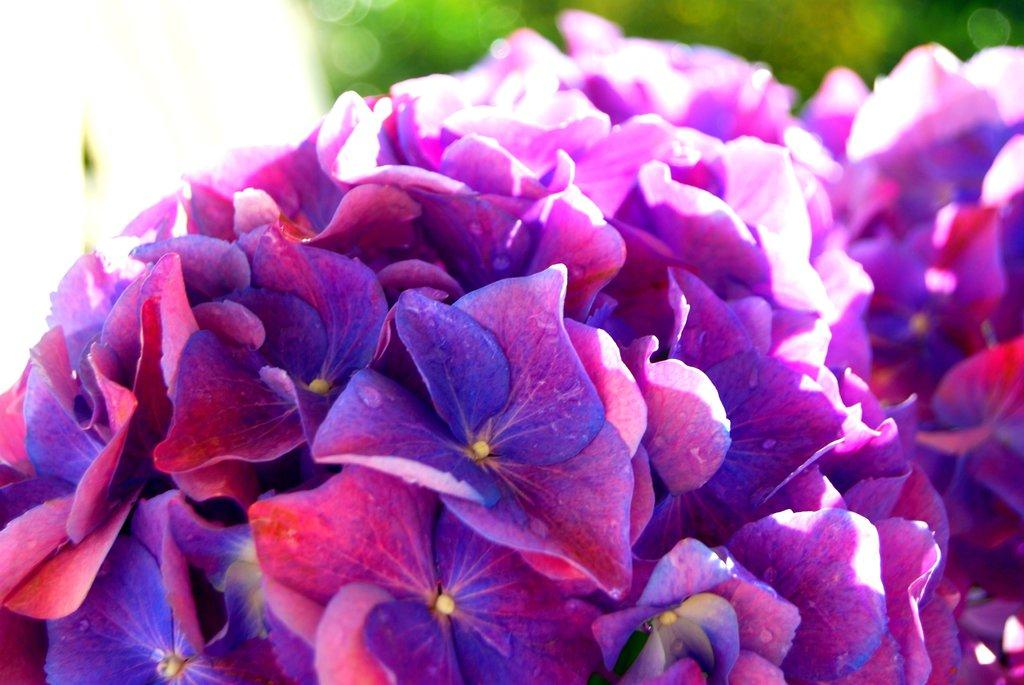What is the main subject of the image? The main subject of the image is a close-up view of flowers. Can you describe the flowers in the image? Unfortunately, the facts provided do not give any details about the flowers, so we cannot describe them. What might be the purpose of taking a close-up view of flowers? A close-up view of flowers could be used to showcase their intricate details, colors, and textures. What type of sock is the porter wearing while resting in the image? There is no porter or sock present in the image; it features a close-up view of flowers. 